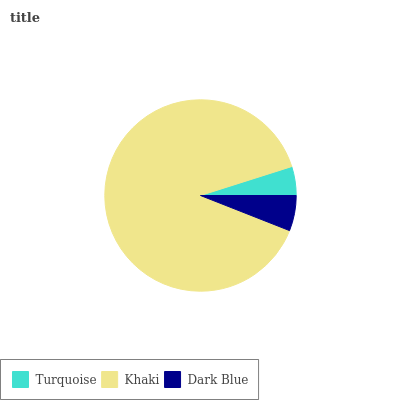Is Turquoise the minimum?
Answer yes or no. Yes. Is Khaki the maximum?
Answer yes or no. Yes. Is Dark Blue the minimum?
Answer yes or no. No. Is Dark Blue the maximum?
Answer yes or no. No. Is Khaki greater than Dark Blue?
Answer yes or no. Yes. Is Dark Blue less than Khaki?
Answer yes or no. Yes. Is Dark Blue greater than Khaki?
Answer yes or no. No. Is Khaki less than Dark Blue?
Answer yes or no. No. Is Dark Blue the high median?
Answer yes or no. Yes. Is Dark Blue the low median?
Answer yes or no. Yes. Is Turquoise the high median?
Answer yes or no. No. Is Khaki the low median?
Answer yes or no. No. 